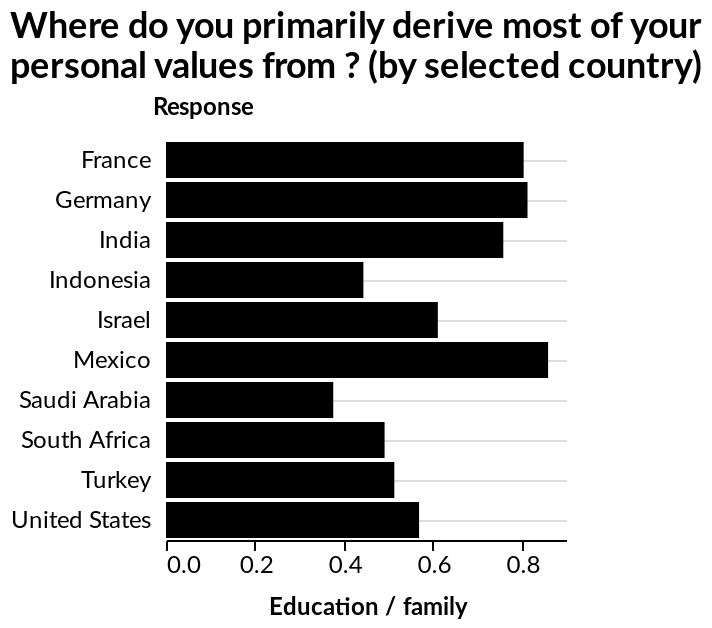<image>
What is the main source from which Mexico derives their personal values? Mexico mainly derives their personal values from education. Which countries closely follow Mexico in deriving their personal values from education? Germany and France closely follow Mexico in deriving their personal values from education. Which countries derive their personal values from education after Mexico? Germany and France derive their personal values from education after Mexico. What does the x-axis represent in the bar diagram?   The x-axis represents Education / family in the bar diagram. 